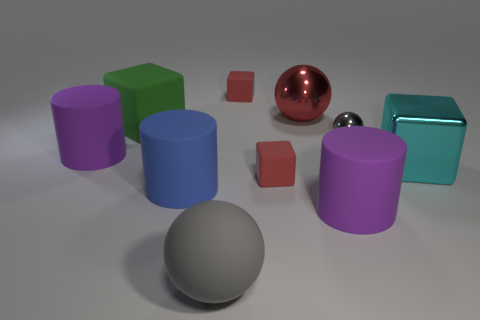Subtract all purple blocks. Subtract all cyan cylinders. How many blocks are left? 4 Subtract all balls. How many objects are left? 7 Add 2 big blue objects. How many big blue objects exist? 3 Subtract 0 gray cylinders. How many objects are left? 10 Subtract all cyan blocks. Subtract all large cylinders. How many objects are left? 6 Add 7 red cubes. How many red cubes are left? 9 